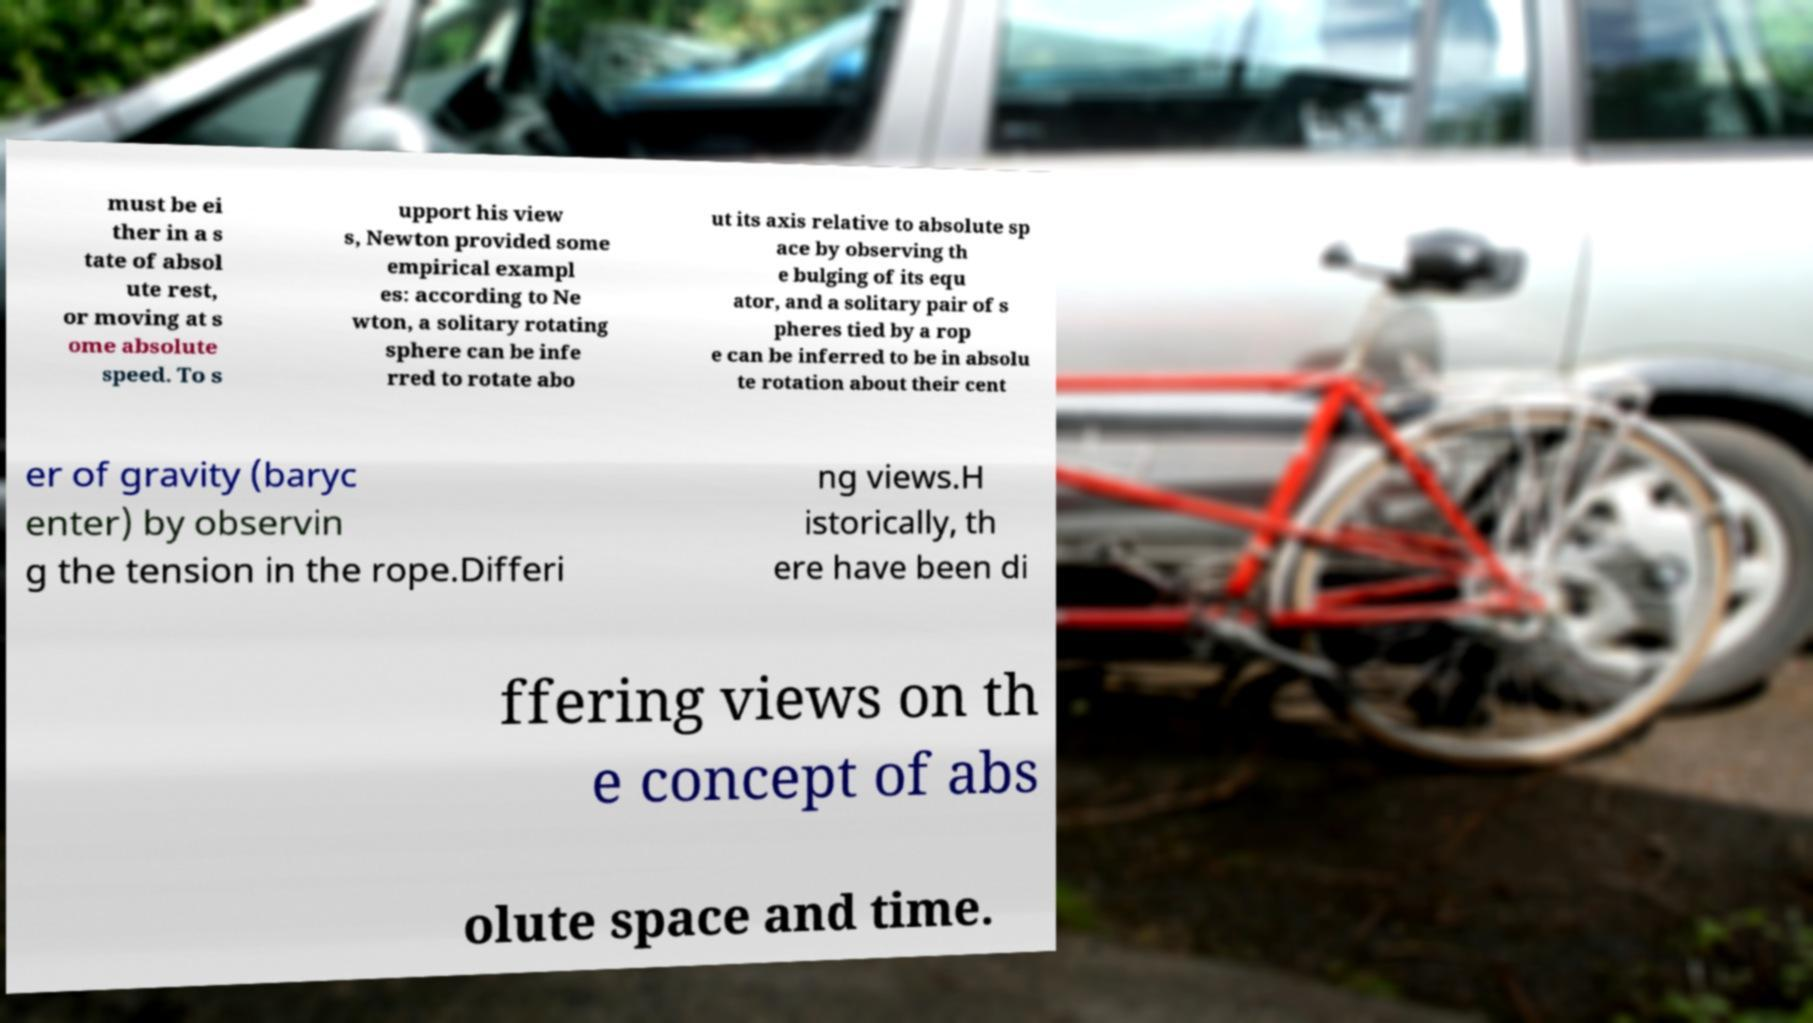There's text embedded in this image that I need extracted. Can you transcribe it verbatim? must be ei ther in a s tate of absol ute rest, or moving at s ome absolute speed. To s upport his view s, Newton provided some empirical exampl es: according to Ne wton, a solitary rotating sphere can be infe rred to rotate abo ut its axis relative to absolute sp ace by observing th e bulging of its equ ator, and a solitary pair of s pheres tied by a rop e can be inferred to be in absolu te rotation about their cent er of gravity (baryc enter) by observin g the tension in the rope.Differi ng views.H istorically, th ere have been di ffering views on th e concept of abs olute space and time. 